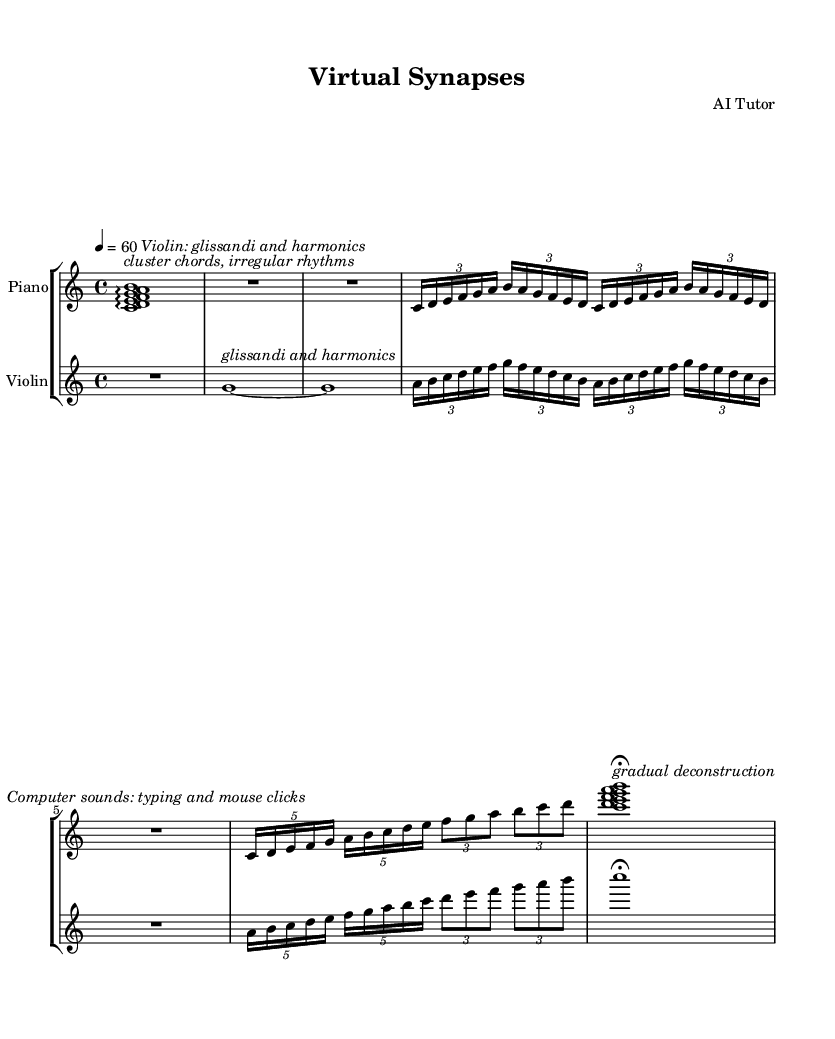What is the time signature of this piece? The time signature is indicated at the beginning of the piece with "4/4", which means there are four beats in each measure.
Answer: 4/4 What is the tempo marking? The tempo marking is shown as "4 = 60", indicating the quarter note receives 60 beats per minute.
Answer: 60 Which instruments are featured in this score? The score includes a "Piano" and a "Violin", as stated in the staff group labels.
Answer: Piano, Violin What type of chords are indicated at the beginning? The introduction describes the chords as "cluster chords, irregular rhythms", which suggests a unique and non-traditional approach to harmony.
Answer: cluster chords, irregular rhythms What is the unique element that appears in the interlude? The interlude features "Computer sounds: typing and mouse clicks," adding an experimental and digital texture to the performance.
Answer: computer sounds: typing and mouse clicks How do the musical sections progress in terms of complexity? The sections evolve from simple glissandi in Section A to more complex tuplets in Sections B and C, indicating a build in texture and intricacy.
Answer: gradual increase in complexity What is indicated by the coda marking? The coda ends with "gradual deconstruction," suggesting a thematic resolution that reduces the musical material back to its simpler forms.
Answer: gradual deconstruction 